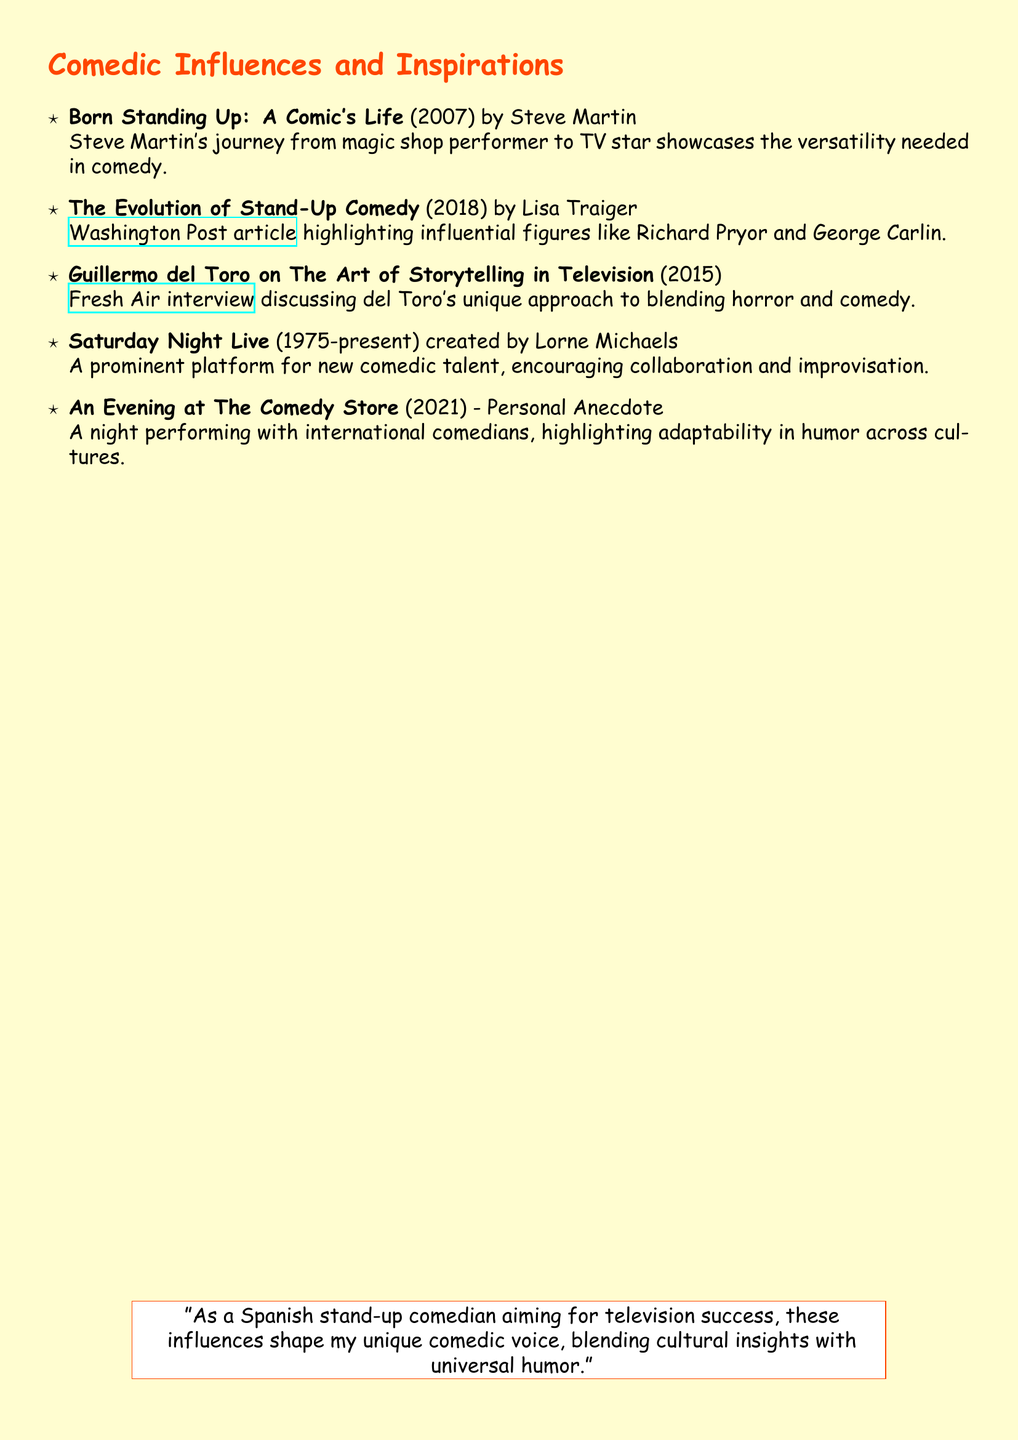What is the title of the book by Steve Martin? The title of Steve Martin's book is mentioned in the document under his entry, which is "Born Standing Up: A Comic's Life."
Answer: Born Standing Up: A Comic's Life Who created Saturday Night Live? The document specifies that Saturday Night Live was created by Lorne Michaels.
Answer: Lorne Michaels What year was The Evolution of Stand-Up Comedy published? The publication year for The Evolution of Stand-Up Comedy is clearly stated as 2018.
Answer: 2018 Which comedian is highlighted for his storytelling in television? The document mentions Guillermo del Toro as a significant figure for his storytelling in television.
Answer: Guillermo del Toro What type of performance is mentioned in the personal anecdote titled An Evening at The Comedy Store? The personal anecdote describes a night of performing with international comedians.
Answer: Performing What main theme influences your comedic style according to the quotation? The quotation in the document highlights blending cultural insights with universal humor as a main theme.
Answer: Blending cultural insights with universal humor In what year was Guillermo del Toro interviewed for the Fresh Air segment? The document indicates that the interview occurred in 2015.
Answer: 2015 Which influential comedian is mentioned alongside Richard Pryor in The Evolution of Stand-Up Comedy? George Carlin is mentioned alongside Richard Pryor in the document.
Answer: George Carlin 